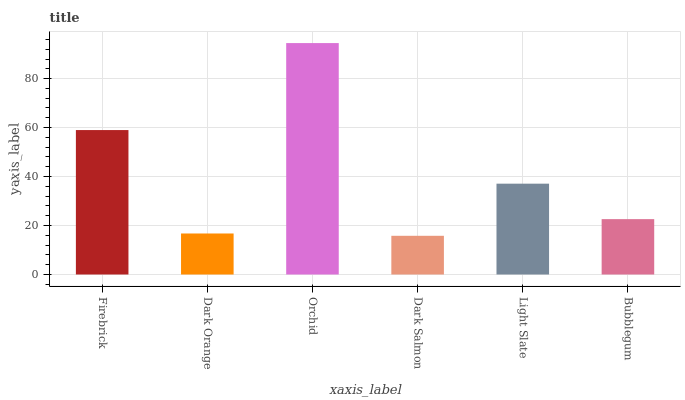Is Dark Salmon the minimum?
Answer yes or no. Yes. Is Orchid the maximum?
Answer yes or no. Yes. Is Dark Orange the minimum?
Answer yes or no. No. Is Dark Orange the maximum?
Answer yes or no. No. Is Firebrick greater than Dark Orange?
Answer yes or no. Yes. Is Dark Orange less than Firebrick?
Answer yes or no. Yes. Is Dark Orange greater than Firebrick?
Answer yes or no. No. Is Firebrick less than Dark Orange?
Answer yes or no. No. Is Light Slate the high median?
Answer yes or no. Yes. Is Bubblegum the low median?
Answer yes or no. Yes. Is Dark Salmon the high median?
Answer yes or no. No. Is Dark Salmon the low median?
Answer yes or no. No. 